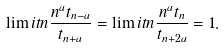Convert formula to latex. <formula><loc_0><loc_0><loc_500><loc_500>\lim i t { n } \frac { n ^ { a } t _ { n - a } } { t _ { n + a } } = \lim i t { n } \frac { n ^ { a } t _ { n } } { t _ { n + 2 a } } = 1 .</formula> 